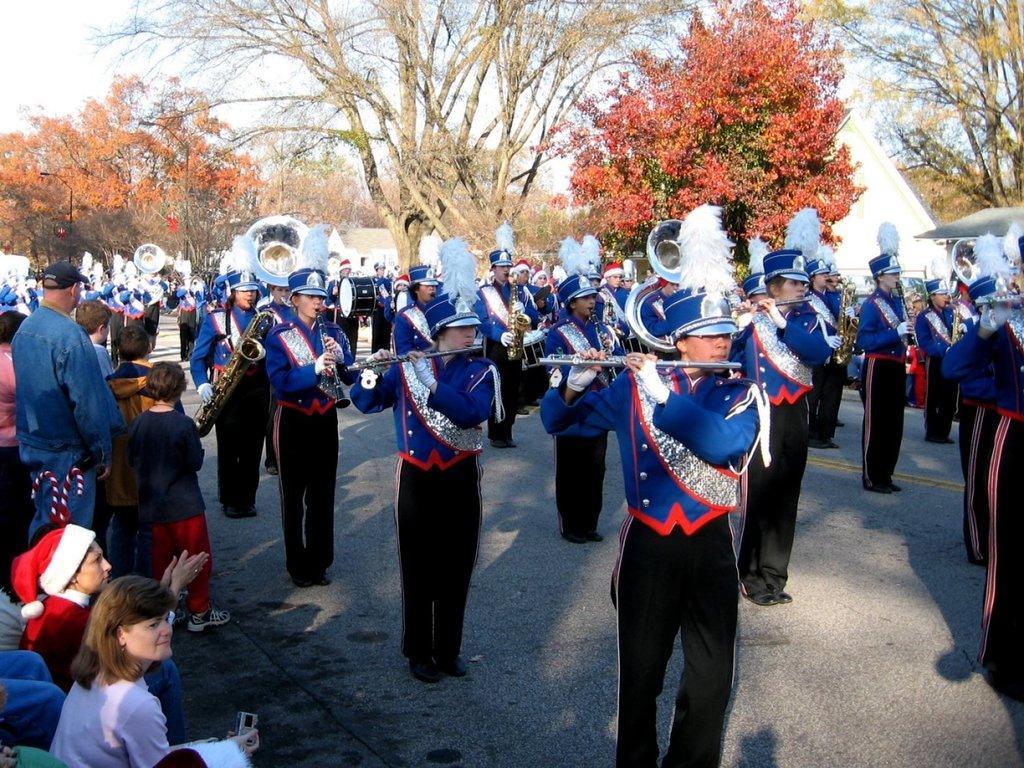Please provide a concise description of this image. In the middle of the image few people are standing and playing some musical instruments. Behind them there are some trees. Behind the trees there is sky. In the bottom left corner of the image few people are standing and sitting. 